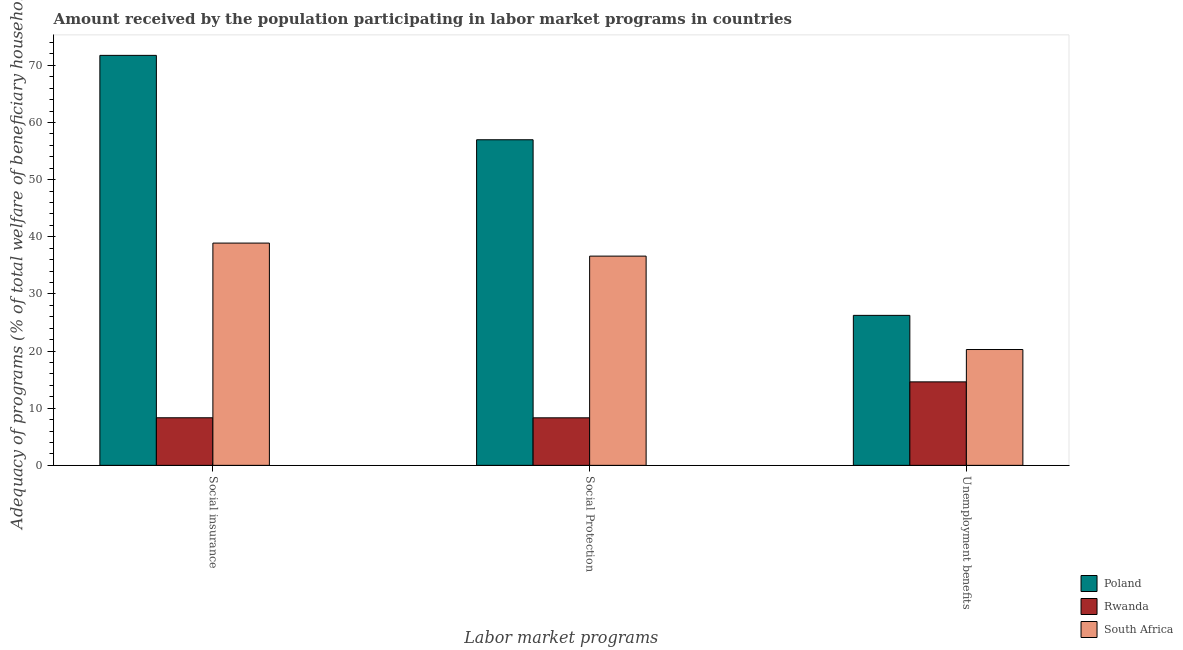How many groups of bars are there?
Provide a succinct answer. 3. Are the number of bars per tick equal to the number of legend labels?
Ensure brevity in your answer.  Yes. Are the number of bars on each tick of the X-axis equal?
Your answer should be compact. Yes. How many bars are there on the 2nd tick from the right?
Offer a terse response. 3. What is the label of the 1st group of bars from the left?
Offer a terse response. Social insurance. What is the amount received by the population participating in unemployment benefits programs in South Africa?
Make the answer very short. 20.27. Across all countries, what is the maximum amount received by the population participating in social protection programs?
Your answer should be compact. 56.99. Across all countries, what is the minimum amount received by the population participating in unemployment benefits programs?
Your response must be concise. 14.61. In which country was the amount received by the population participating in social insurance programs minimum?
Give a very brief answer. Rwanda. What is the total amount received by the population participating in social insurance programs in the graph?
Make the answer very short. 118.98. What is the difference between the amount received by the population participating in social insurance programs in South Africa and that in Poland?
Provide a short and direct response. -32.85. What is the difference between the amount received by the population participating in social insurance programs in Poland and the amount received by the population participating in unemployment benefits programs in Rwanda?
Your answer should be very brief. 57.14. What is the average amount received by the population participating in social protection programs per country?
Provide a succinct answer. 33.98. What is the difference between the amount received by the population participating in social insurance programs and amount received by the population participating in social protection programs in Poland?
Ensure brevity in your answer.  14.77. In how many countries, is the amount received by the population participating in social protection programs greater than 52 %?
Your answer should be very brief. 1. What is the ratio of the amount received by the population participating in social protection programs in Poland to that in Rwanda?
Give a very brief answer. 6.85. Is the difference between the amount received by the population participating in social protection programs in South Africa and Poland greater than the difference between the amount received by the population participating in social insurance programs in South Africa and Poland?
Your answer should be very brief. Yes. What is the difference between the highest and the second highest amount received by the population participating in unemployment benefits programs?
Your response must be concise. 5.98. What is the difference between the highest and the lowest amount received by the population participating in social insurance programs?
Your response must be concise. 63.43. In how many countries, is the amount received by the population participating in unemployment benefits programs greater than the average amount received by the population participating in unemployment benefits programs taken over all countries?
Offer a terse response. 1. What does the 3rd bar from the left in Social insurance represents?
Ensure brevity in your answer.  South Africa. What does the 1st bar from the right in Unemployment benefits represents?
Offer a terse response. South Africa. Is it the case that in every country, the sum of the amount received by the population participating in social insurance programs and amount received by the population participating in social protection programs is greater than the amount received by the population participating in unemployment benefits programs?
Your answer should be very brief. Yes. How many bars are there?
Give a very brief answer. 9. Are all the bars in the graph horizontal?
Offer a very short reply. No. How many countries are there in the graph?
Keep it short and to the point. 3. Are the values on the major ticks of Y-axis written in scientific E-notation?
Ensure brevity in your answer.  No. Where does the legend appear in the graph?
Provide a succinct answer. Bottom right. How are the legend labels stacked?
Ensure brevity in your answer.  Vertical. What is the title of the graph?
Your answer should be very brief. Amount received by the population participating in labor market programs in countries. What is the label or title of the X-axis?
Give a very brief answer. Labor market programs. What is the label or title of the Y-axis?
Provide a short and direct response. Adequacy of programs (% of total welfare of beneficiary households). What is the Adequacy of programs (% of total welfare of beneficiary households) of Poland in Social insurance?
Offer a very short reply. 71.75. What is the Adequacy of programs (% of total welfare of beneficiary households) in Rwanda in Social insurance?
Your answer should be compact. 8.33. What is the Adequacy of programs (% of total welfare of beneficiary households) of South Africa in Social insurance?
Offer a terse response. 38.9. What is the Adequacy of programs (% of total welfare of beneficiary households) of Poland in Social Protection?
Offer a terse response. 56.99. What is the Adequacy of programs (% of total welfare of beneficiary households) in Rwanda in Social Protection?
Provide a short and direct response. 8.32. What is the Adequacy of programs (% of total welfare of beneficiary households) in South Africa in Social Protection?
Your answer should be compact. 36.62. What is the Adequacy of programs (% of total welfare of beneficiary households) in Poland in Unemployment benefits?
Provide a short and direct response. 26.25. What is the Adequacy of programs (% of total welfare of beneficiary households) in Rwanda in Unemployment benefits?
Ensure brevity in your answer.  14.61. What is the Adequacy of programs (% of total welfare of beneficiary households) in South Africa in Unemployment benefits?
Provide a succinct answer. 20.27. Across all Labor market programs, what is the maximum Adequacy of programs (% of total welfare of beneficiary households) of Poland?
Your answer should be very brief. 71.75. Across all Labor market programs, what is the maximum Adequacy of programs (% of total welfare of beneficiary households) of Rwanda?
Provide a short and direct response. 14.61. Across all Labor market programs, what is the maximum Adequacy of programs (% of total welfare of beneficiary households) of South Africa?
Ensure brevity in your answer.  38.9. Across all Labor market programs, what is the minimum Adequacy of programs (% of total welfare of beneficiary households) in Poland?
Give a very brief answer. 26.25. Across all Labor market programs, what is the minimum Adequacy of programs (% of total welfare of beneficiary households) of Rwanda?
Provide a succinct answer. 8.32. Across all Labor market programs, what is the minimum Adequacy of programs (% of total welfare of beneficiary households) in South Africa?
Offer a very short reply. 20.27. What is the total Adequacy of programs (% of total welfare of beneficiary households) in Poland in the graph?
Ensure brevity in your answer.  154.99. What is the total Adequacy of programs (% of total welfare of beneficiary households) in Rwanda in the graph?
Provide a succinct answer. 31.26. What is the total Adequacy of programs (% of total welfare of beneficiary households) of South Africa in the graph?
Make the answer very short. 95.79. What is the difference between the Adequacy of programs (% of total welfare of beneficiary households) in Poland in Social insurance and that in Social Protection?
Your answer should be compact. 14.77. What is the difference between the Adequacy of programs (% of total welfare of beneficiary households) of Rwanda in Social insurance and that in Social Protection?
Provide a succinct answer. 0.01. What is the difference between the Adequacy of programs (% of total welfare of beneficiary households) of South Africa in Social insurance and that in Social Protection?
Offer a terse response. 2.28. What is the difference between the Adequacy of programs (% of total welfare of beneficiary households) in Poland in Social insurance and that in Unemployment benefits?
Keep it short and to the point. 45.5. What is the difference between the Adequacy of programs (% of total welfare of beneficiary households) of Rwanda in Social insurance and that in Unemployment benefits?
Your answer should be compact. -6.28. What is the difference between the Adequacy of programs (% of total welfare of beneficiary households) in South Africa in Social insurance and that in Unemployment benefits?
Give a very brief answer. 18.63. What is the difference between the Adequacy of programs (% of total welfare of beneficiary households) in Poland in Social Protection and that in Unemployment benefits?
Your response must be concise. 30.74. What is the difference between the Adequacy of programs (% of total welfare of beneficiary households) in Rwanda in Social Protection and that in Unemployment benefits?
Offer a terse response. -6.29. What is the difference between the Adequacy of programs (% of total welfare of beneficiary households) of South Africa in Social Protection and that in Unemployment benefits?
Ensure brevity in your answer.  16.35. What is the difference between the Adequacy of programs (% of total welfare of beneficiary households) of Poland in Social insurance and the Adequacy of programs (% of total welfare of beneficiary households) of Rwanda in Social Protection?
Your answer should be very brief. 63.43. What is the difference between the Adequacy of programs (% of total welfare of beneficiary households) in Poland in Social insurance and the Adequacy of programs (% of total welfare of beneficiary households) in South Africa in Social Protection?
Your answer should be very brief. 35.13. What is the difference between the Adequacy of programs (% of total welfare of beneficiary households) in Rwanda in Social insurance and the Adequacy of programs (% of total welfare of beneficiary households) in South Africa in Social Protection?
Keep it short and to the point. -28.29. What is the difference between the Adequacy of programs (% of total welfare of beneficiary households) of Poland in Social insurance and the Adequacy of programs (% of total welfare of beneficiary households) of Rwanda in Unemployment benefits?
Keep it short and to the point. 57.14. What is the difference between the Adequacy of programs (% of total welfare of beneficiary households) of Poland in Social insurance and the Adequacy of programs (% of total welfare of beneficiary households) of South Africa in Unemployment benefits?
Ensure brevity in your answer.  51.48. What is the difference between the Adequacy of programs (% of total welfare of beneficiary households) in Rwanda in Social insurance and the Adequacy of programs (% of total welfare of beneficiary households) in South Africa in Unemployment benefits?
Your response must be concise. -11.94. What is the difference between the Adequacy of programs (% of total welfare of beneficiary households) in Poland in Social Protection and the Adequacy of programs (% of total welfare of beneficiary households) in Rwanda in Unemployment benefits?
Your answer should be compact. 42.38. What is the difference between the Adequacy of programs (% of total welfare of beneficiary households) of Poland in Social Protection and the Adequacy of programs (% of total welfare of beneficiary households) of South Africa in Unemployment benefits?
Offer a very short reply. 36.71. What is the difference between the Adequacy of programs (% of total welfare of beneficiary households) in Rwanda in Social Protection and the Adequacy of programs (% of total welfare of beneficiary households) in South Africa in Unemployment benefits?
Your answer should be compact. -11.95. What is the average Adequacy of programs (% of total welfare of beneficiary households) in Poland per Labor market programs?
Offer a very short reply. 51.66. What is the average Adequacy of programs (% of total welfare of beneficiary households) of Rwanda per Labor market programs?
Your response must be concise. 10.42. What is the average Adequacy of programs (% of total welfare of beneficiary households) of South Africa per Labor market programs?
Make the answer very short. 31.93. What is the difference between the Adequacy of programs (% of total welfare of beneficiary households) of Poland and Adequacy of programs (% of total welfare of beneficiary households) of Rwanda in Social insurance?
Ensure brevity in your answer.  63.43. What is the difference between the Adequacy of programs (% of total welfare of beneficiary households) of Poland and Adequacy of programs (% of total welfare of beneficiary households) of South Africa in Social insurance?
Provide a short and direct response. 32.85. What is the difference between the Adequacy of programs (% of total welfare of beneficiary households) of Rwanda and Adequacy of programs (% of total welfare of beneficiary households) of South Africa in Social insurance?
Your answer should be compact. -30.57. What is the difference between the Adequacy of programs (% of total welfare of beneficiary households) in Poland and Adequacy of programs (% of total welfare of beneficiary households) in Rwanda in Social Protection?
Provide a short and direct response. 48.67. What is the difference between the Adequacy of programs (% of total welfare of beneficiary households) in Poland and Adequacy of programs (% of total welfare of beneficiary households) in South Africa in Social Protection?
Provide a succinct answer. 20.36. What is the difference between the Adequacy of programs (% of total welfare of beneficiary households) in Rwanda and Adequacy of programs (% of total welfare of beneficiary households) in South Africa in Social Protection?
Offer a very short reply. -28.3. What is the difference between the Adequacy of programs (% of total welfare of beneficiary households) of Poland and Adequacy of programs (% of total welfare of beneficiary households) of Rwanda in Unemployment benefits?
Your answer should be very brief. 11.64. What is the difference between the Adequacy of programs (% of total welfare of beneficiary households) in Poland and Adequacy of programs (% of total welfare of beneficiary households) in South Africa in Unemployment benefits?
Make the answer very short. 5.98. What is the difference between the Adequacy of programs (% of total welfare of beneficiary households) of Rwanda and Adequacy of programs (% of total welfare of beneficiary households) of South Africa in Unemployment benefits?
Provide a short and direct response. -5.66. What is the ratio of the Adequacy of programs (% of total welfare of beneficiary households) of Poland in Social insurance to that in Social Protection?
Give a very brief answer. 1.26. What is the ratio of the Adequacy of programs (% of total welfare of beneficiary households) of Rwanda in Social insurance to that in Social Protection?
Your answer should be very brief. 1. What is the ratio of the Adequacy of programs (% of total welfare of beneficiary households) in South Africa in Social insurance to that in Social Protection?
Give a very brief answer. 1.06. What is the ratio of the Adequacy of programs (% of total welfare of beneficiary households) of Poland in Social insurance to that in Unemployment benefits?
Your answer should be compact. 2.73. What is the ratio of the Adequacy of programs (% of total welfare of beneficiary households) in Rwanda in Social insurance to that in Unemployment benefits?
Offer a terse response. 0.57. What is the ratio of the Adequacy of programs (% of total welfare of beneficiary households) of South Africa in Social insurance to that in Unemployment benefits?
Provide a succinct answer. 1.92. What is the ratio of the Adequacy of programs (% of total welfare of beneficiary households) of Poland in Social Protection to that in Unemployment benefits?
Your answer should be very brief. 2.17. What is the ratio of the Adequacy of programs (% of total welfare of beneficiary households) of Rwanda in Social Protection to that in Unemployment benefits?
Your answer should be very brief. 0.57. What is the ratio of the Adequacy of programs (% of total welfare of beneficiary households) in South Africa in Social Protection to that in Unemployment benefits?
Ensure brevity in your answer.  1.81. What is the difference between the highest and the second highest Adequacy of programs (% of total welfare of beneficiary households) in Poland?
Your answer should be very brief. 14.77. What is the difference between the highest and the second highest Adequacy of programs (% of total welfare of beneficiary households) in Rwanda?
Offer a very short reply. 6.28. What is the difference between the highest and the second highest Adequacy of programs (% of total welfare of beneficiary households) in South Africa?
Provide a short and direct response. 2.28. What is the difference between the highest and the lowest Adequacy of programs (% of total welfare of beneficiary households) of Poland?
Keep it short and to the point. 45.5. What is the difference between the highest and the lowest Adequacy of programs (% of total welfare of beneficiary households) in Rwanda?
Give a very brief answer. 6.29. What is the difference between the highest and the lowest Adequacy of programs (% of total welfare of beneficiary households) of South Africa?
Provide a succinct answer. 18.63. 